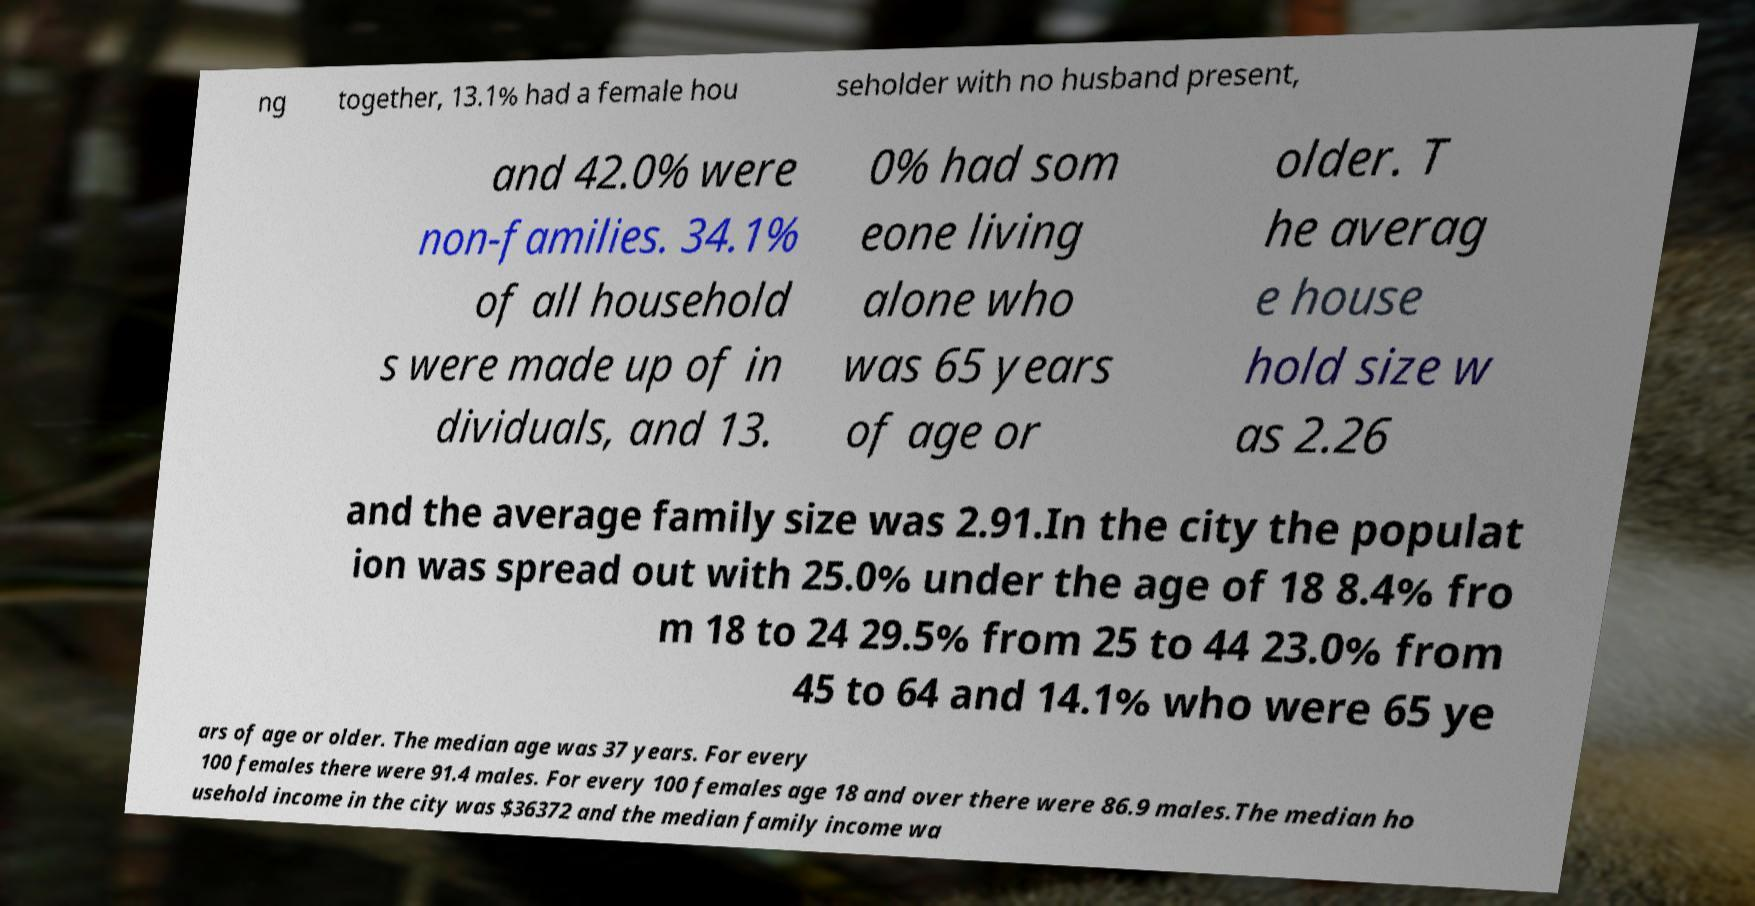Can you read and provide the text displayed in the image?This photo seems to have some interesting text. Can you extract and type it out for me? ng together, 13.1% had a female hou seholder with no husband present, and 42.0% were non-families. 34.1% of all household s were made up of in dividuals, and 13. 0% had som eone living alone who was 65 years of age or older. T he averag e house hold size w as 2.26 and the average family size was 2.91.In the city the populat ion was spread out with 25.0% under the age of 18 8.4% fro m 18 to 24 29.5% from 25 to 44 23.0% from 45 to 64 and 14.1% who were 65 ye ars of age or older. The median age was 37 years. For every 100 females there were 91.4 males. For every 100 females age 18 and over there were 86.9 males.The median ho usehold income in the city was $36372 and the median family income wa 